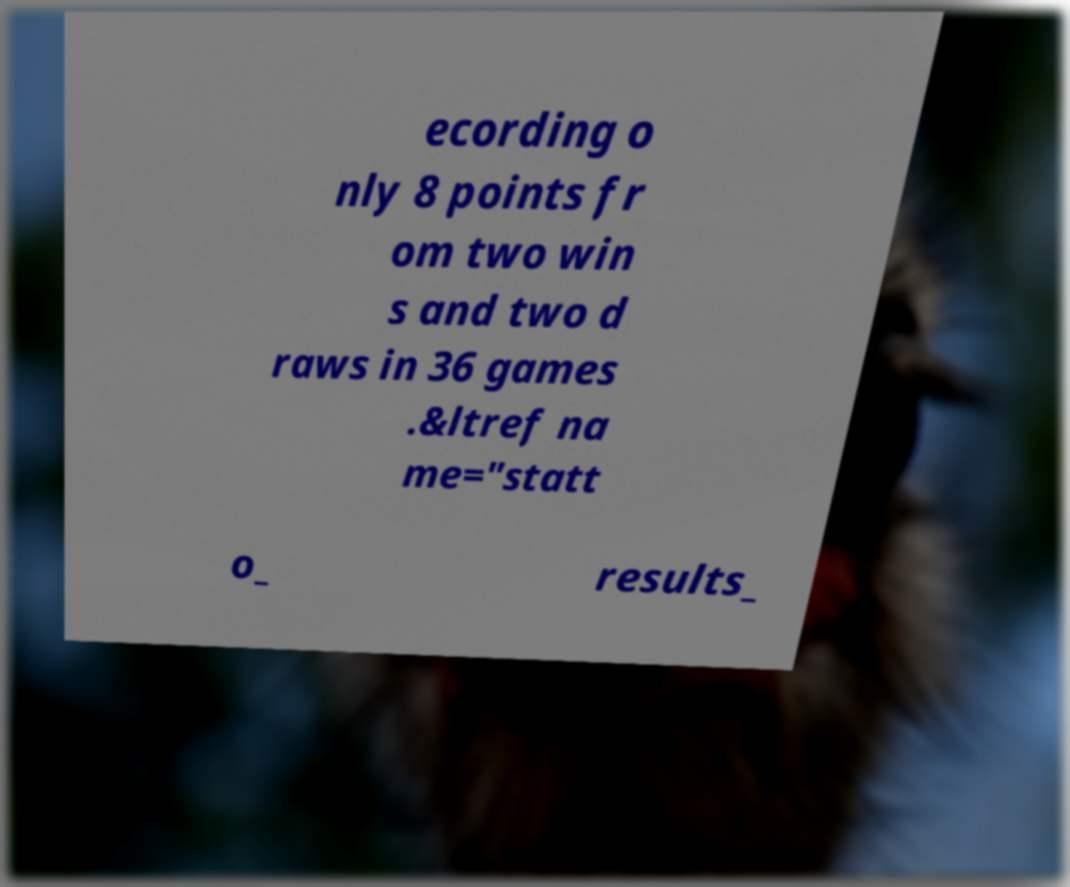Please identify and transcribe the text found in this image. ecording o nly 8 points fr om two win s and two d raws in 36 games .&ltref na me="statt o_ results_ 